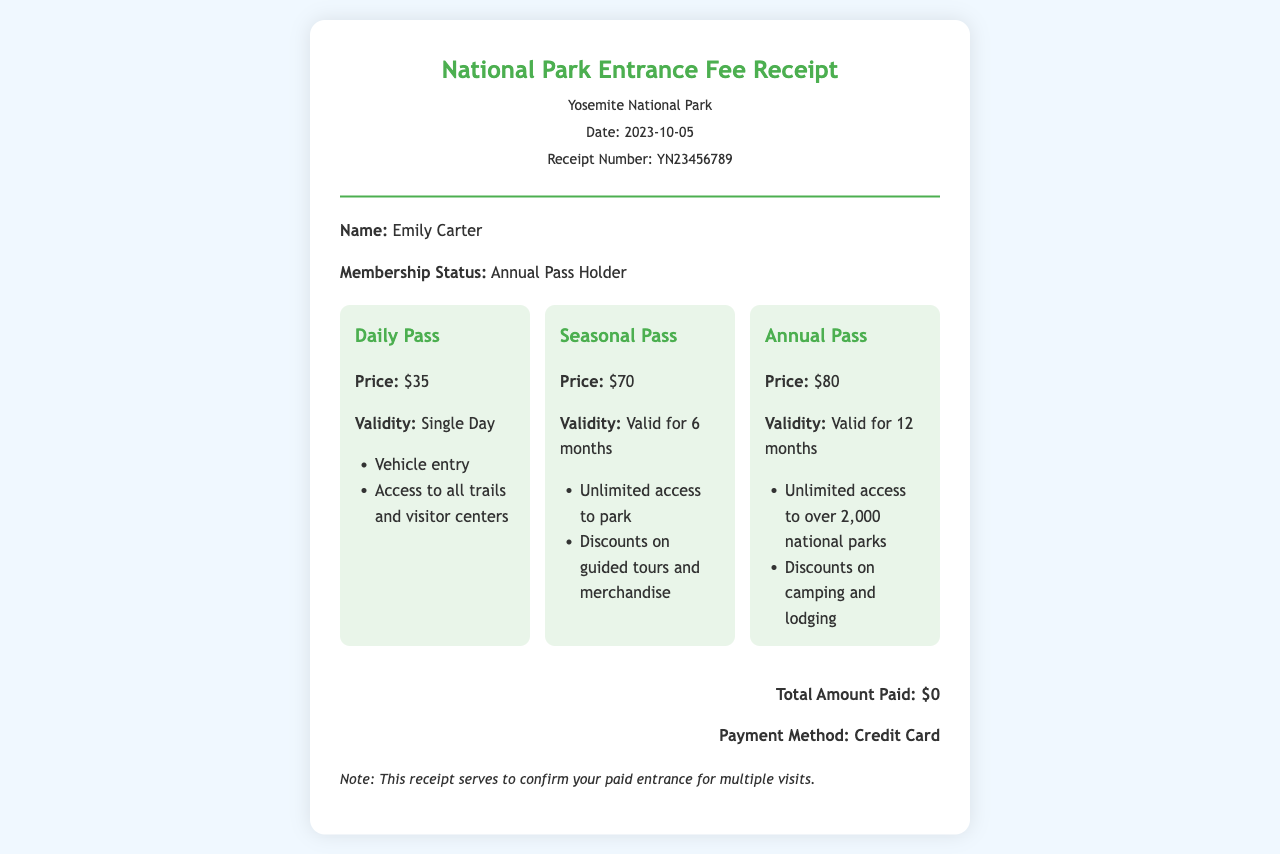What is the date of the receipt? The date of the receipt is stated at the top of the document.
Answer: 2023-10-05 Who is the recipient of the receipt? The recipient's name is mentioned in the visitor details section.
Answer: Emily Carter What is the price of the Daily Pass? The price for the Daily Pass is specified in the fees section.
Answer: $35 What is the validity period of the Seasonal Pass? The validity of the Seasonal Pass is provided in the fee option details.
Answer: Valid for 6 months What is the payment method used? The payment method is indicated in the total section of the receipt.
Answer: Credit Card How much is the Annual Pass? The cost of the Annual Pass is listed among the fee options.
Answer: $80 What does the receipt confirm? The additional info section states the purpose of the receipt.
Answer: Your paid entrance for multiple visits What type of pass is the recipient holding? The membership status section indicates the type of pass held by the recipient.
Answer: Annual Pass Holder How many national parks does the Annual Pass offer access to? The benefits of the Annual Pass include the number of parks listed in its description.
Answer: Over 2,000 national parks 